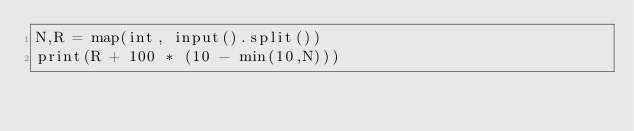Convert code to text. <code><loc_0><loc_0><loc_500><loc_500><_Python_>N,R = map(int, input().split())
print(R + 100 * (10 - min(10,N)))</code> 